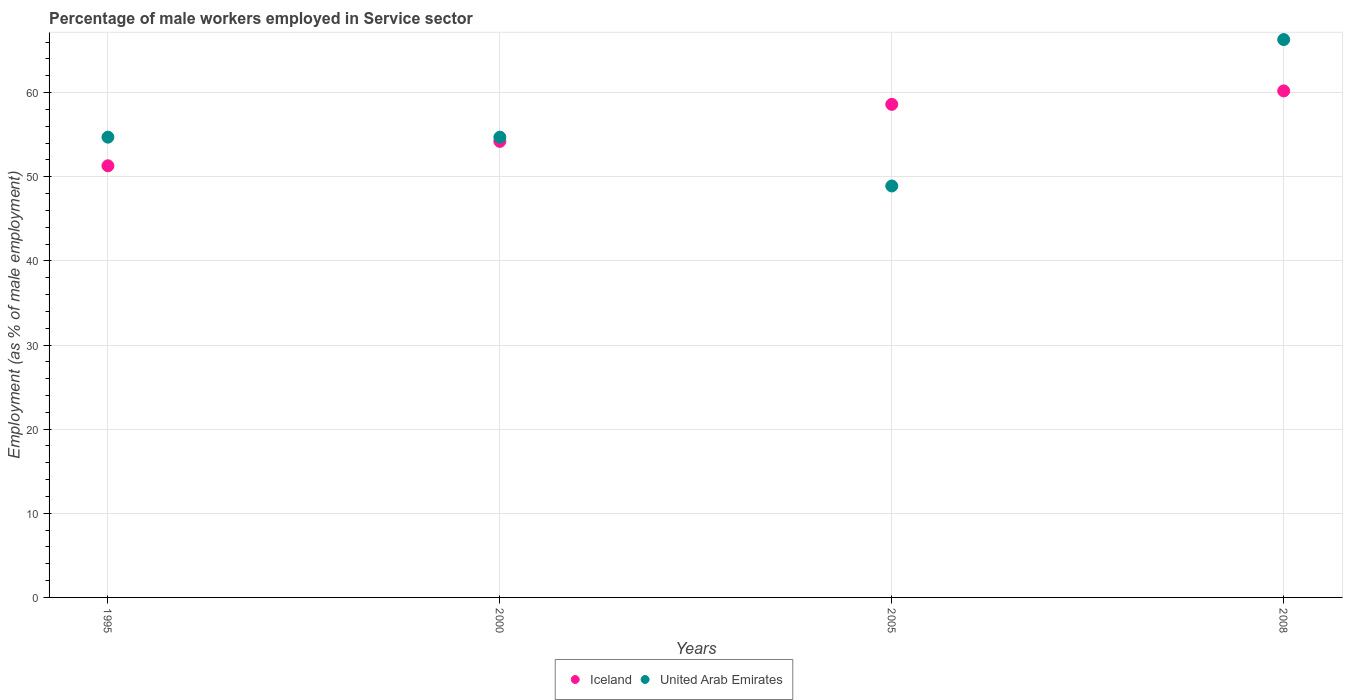How many different coloured dotlines are there?
Your response must be concise. 2. What is the percentage of male workers employed in Service sector in Iceland in 2005?
Give a very brief answer. 58.6. Across all years, what is the maximum percentage of male workers employed in Service sector in United Arab Emirates?
Your answer should be compact. 66.3. Across all years, what is the minimum percentage of male workers employed in Service sector in United Arab Emirates?
Your answer should be compact. 48.9. In which year was the percentage of male workers employed in Service sector in United Arab Emirates minimum?
Offer a very short reply. 2005. What is the total percentage of male workers employed in Service sector in Iceland in the graph?
Keep it short and to the point. 224.3. What is the difference between the percentage of male workers employed in Service sector in United Arab Emirates in 1995 and that in 2008?
Your answer should be compact. -11.6. What is the average percentage of male workers employed in Service sector in Iceland per year?
Your response must be concise. 56.07. In the year 2000, what is the difference between the percentage of male workers employed in Service sector in Iceland and percentage of male workers employed in Service sector in United Arab Emirates?
Your response must be concise. -0.5. What is the ratio of the percentage of male workers employed in Service sector in United Arab Emirates in 1995 to that in 2008?
Your response must be concise. 0.83. What is the difference between the highest and the second highest percentage of male workers employed in Service sector in Iceland?
Make the answer very short. 1.6. What is the difference between the highest and the lowest percentage of male workers employed in Service sector in United Arab Emirates?
Offer a very short reply. 17.4. In how many years, is the percentage of male workers employed in Service sector in United Arab Emirates greater than the average percentage of male workers employed in Service sector in United Arab Emirates taken over all years?
Provide a succinct answer. 1. Is the sum of the percentage of male workers employed in Service sector in Iceland in 2000 and 2008 greater than the maximum percentage of male workers employed in Service sector in United Arab Emirates across all years?
Your response must be concise. Yes. Does the percentage of male workers employed in Service sector in Iceland monotonically increase over the years?
Your response must be concise. Yes. Is the percentage of male workers employed in Service sector in United Arab Emirates strictly less than the percentage of male workers employed in Service sector in Iceland over the years?
Your answer should be compact. No. How many dotlines are there?
Your answer should be very brief. 2. Does the graph contain any zero values?
Offer a terse response. No. Where does the legend appear in the graph?
Provide a succinct answer. Bottom center. How are the legend labels stacked?
Offer a terse response. Horizontal. What is the title of the graph?
Make the answer very short. Percentage of male workers employed in Service sector. What is the label or title of the X-axis?
Offer a terse response. Years. What is the label or title of the Y-axis?
Your answer should be compact. Employment (as % of male employment). What is the Employment (as % of male employment) in Iceland in 1995?
Provide a short and direct response. 51.3. What is the Employment (as % of male employment) in United Arab Emirates in 1995?
Give a very brief answer. 54.7. What is the Employment (as % of male employment) of Iceland in 2000?
Provide a short and direct response. 54.2. What is the Employment (as % of male employment) in United Arab Emirates in 2000?
Provide a short and direct response. 54.7. What is the Employment (as % of male employment) of Iceland in 2005?
Ensure brevity in your answer.  58.6. What is the Employment (as % of male employment) of United Arab Emirates in 2005?
Your answer should be compact. 48.9. What is the Employment (as % of male employment) in Iceland in 2008?
Your response must be concise. 60.2. What is the Employment (as % of male employment) of United Arab Emirates in 2008?
Provide a succinct answer. 66.3. Across all years, what is the maximum Employment (as % of male employment) of Iceland?
Provide a succinct answer. 60.2. Across all years, what is the maximum Employment (as % of male employment) of United Arab Emirates?
Your response must be concise. 66.3. Across all years, what is the minimum Employment (as % of male employment) of Iceland?
Your response must be concise. 51.3. Across all years, what is the minimum Employment (as % of male employment) of United Arab Emirates?
Offer a terse response. 48.9. What is the total Employment (as % of male employment) in Iceland in the graph?
Ensure brevity in your answer.  224.3. What is the total Employment (as % of male employment) of United Arab Emirates in the graph?
Make the answer very short. 224.6. What is the difference between the Employment (as % of male employment) of United Arab Emirates in 1995 and that in 2005?
Make the answer very short. 5.8. What is the difference between the Employment (as % of male employment) in Iceland in 1995 and that in 2008?
Provide a short and direct response. -8.9. What is the difference between the Employment (as % of male employment) of Iceland in 2000 and that in 2008?
Provide a succinct answer. -6. What is the difference between the Employment (as % of male employment) in United Arab Emirates in 2000 and that in 2008?
Provide a succinct answer. -11.6. What is the difference between the Employment (as % of male employment) in Iceland in 2005 and that in 2008?
Make the answer very short. -1.6. What is the difference between the Employment (as % of male employment) of United Arab Emirates in 2005 and that in 2008?
Your answer should be compact. -17.4. What is the difference between the Employment (as % of male employment) of Iceland in 1995 and the Employment (as % of male employment) of United Arab Emirates in 2005?
Provide a succinct answer. 2.4. What is the difference between the Employment (as % of male employment) in Iceland in 2000 and the Employment (as % of male employment) in United Arab Emirates in 2005?
Your answer should be very brief. 5.3. What is the difference between the Employment (as % of male employment) of Iceland in 2000 and the Employment (as % of male employment) of United Arab Emirates in 2008?
Offer a very short reply. -12.1. What is the average Employment (as % of male employment) in Iceland per year?
Give a very brief answer. 56.08. What is the average Employment (as % of male employment) in United Arab Emirates per year?
Give a very brief answer. 56.15. In the year 1995, what is the difference between the Employment (as % of male employment) of Iceland and Employment (as % of male employment) of United Arab Emirates?
Provide a short and direct response. -3.4. In the year 2005, what is the difference between the Employment (as % of male employment) in Iceland and Employment (as % of male employment) in United Arab Emirates?
Provide a succinct answer. 9.7. What is the ratio of the Employment (as % of male employment) in Iceland in 1995 to that in 2000?
Provide a short and direct response. 0.95. What is the ratio of the Employment (as % of male employment) of United Arab Emirates in 1995 to that in 2000?
Make the answer very short. 1. What is the ratio of the Employment (as % of male employment) in Iceland in 1995 to that in 2005?
Your response must be concise. 0.88. What is the ratio of the Employment (as % of male employment) in United Arab Emirates in 1995 to that in 2005?
Offer a terse response. 1.12. What is the ratio of the Employment (as % of male employment) of Iceland in 1995 to that in 2008?
Your answer should be very brief. 0.85. What is the ratio of the Employment (as % of male employment) of United Arab Emirates in 1995 to that in 2008?
Keep it short and to the point. 0.82. What is the ratio of the Employment (as % of male employment) in Iceland in 2000 to that in 2005?
Your answer should be very brief. 0.92. What is the ratio of the Employment (as % of male employment) in United Arab Emirates in 2000 to that in 2005?
Offer a very short reply. 1.12. What is the ratio of the Employment (as % of male employment) of Iceland in 2000 to that in 2008?
Keep it short and to the point. 0.9. What is the ratio of the Employment (as % of male employment) of United Arab Emirates in 2000 to that in 2008?
Ensure brevity in your answer.  0.82. What is the ratio of the Employment (as % of male employment) of Iceland in 2005 to that in 2008?
Keep it short and to the point. 0.97. What is the ratio of the Employment (as % of male employment) in United Arab Emirates in 2005 to that in 2008?
Your response must be concise. 0.74. What is the difference between the highest and the second highest Employment (as % of male employment) in Iceland?
Make the answer very short. 1.6. What is the difference between the highest and the second highest Employment (as % of male employment) of United Arab Emirates?
Your response must be concise. 11.6. What is the difference between the highest and the lowest Employment (as % of male employment) in Iceland?
Keep it short and to the point. 8.9. What is the difference between the highest and the lowest Employment (as % of male employment) of United Arab Emirates?
Make the answer very short. 17.4. 